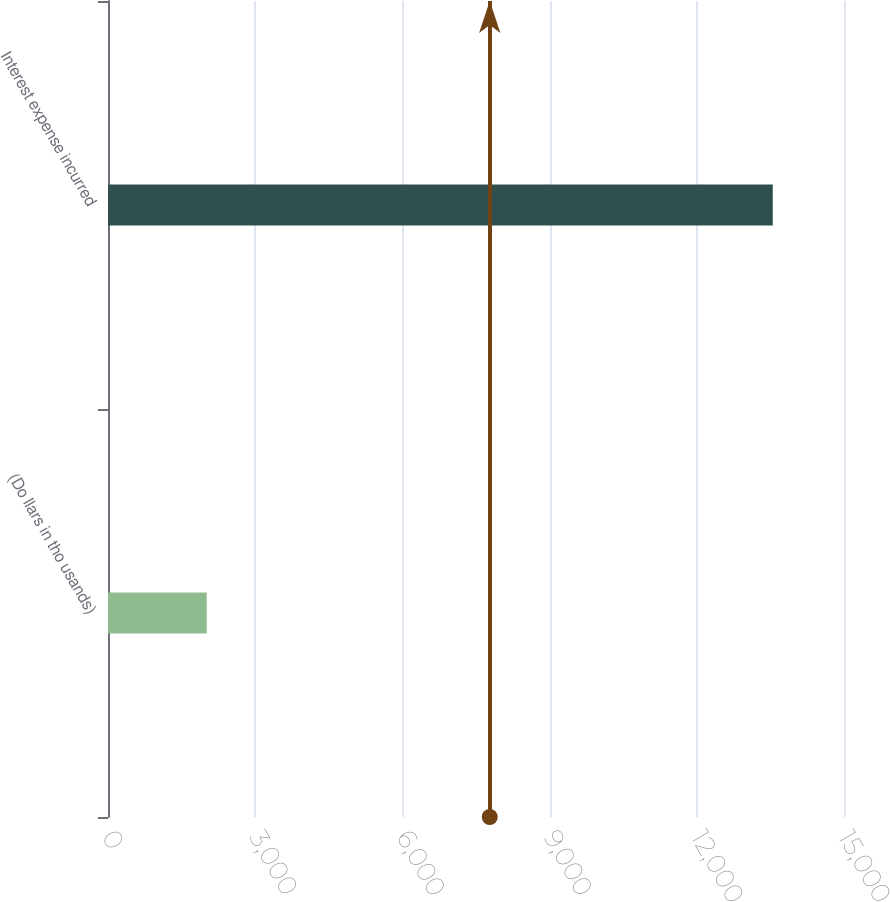<chart> <loc_0><loc_0><loc_500><loc_500><bar_chart><fcel>(Do llars in tho usands)<fcel>Interest expense incurred<nl><fcel>2012<fcel>13548<nl></chart> 